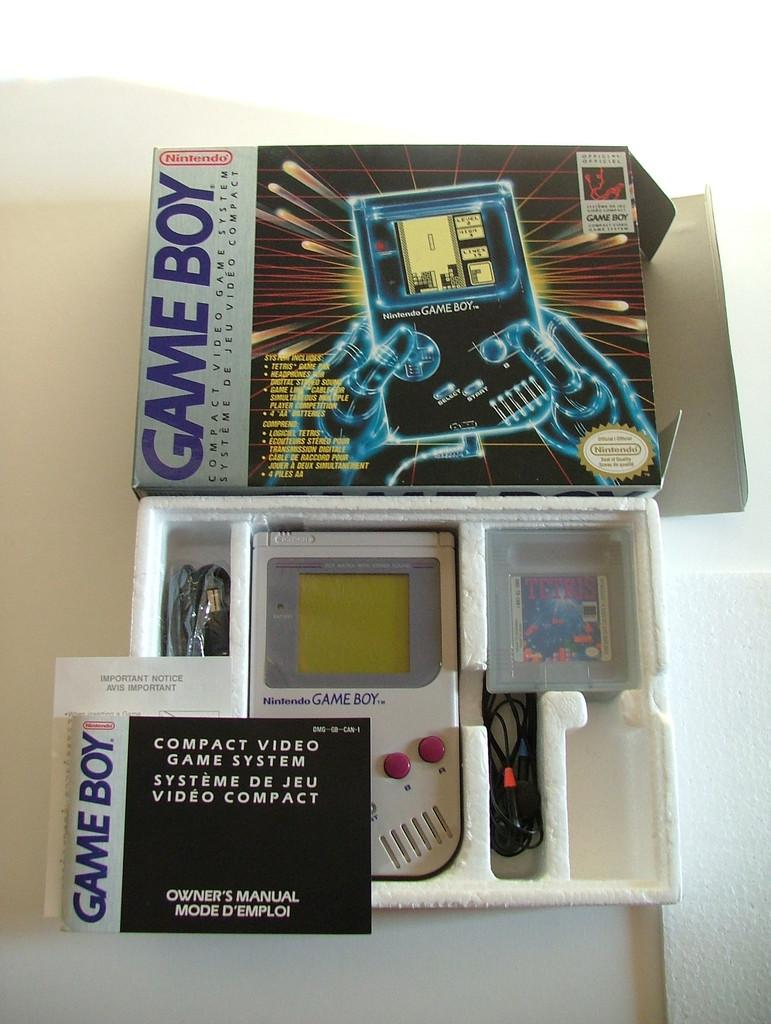<image>
Describe the image concisely. A  Gameboy complete with its' original packaging. 